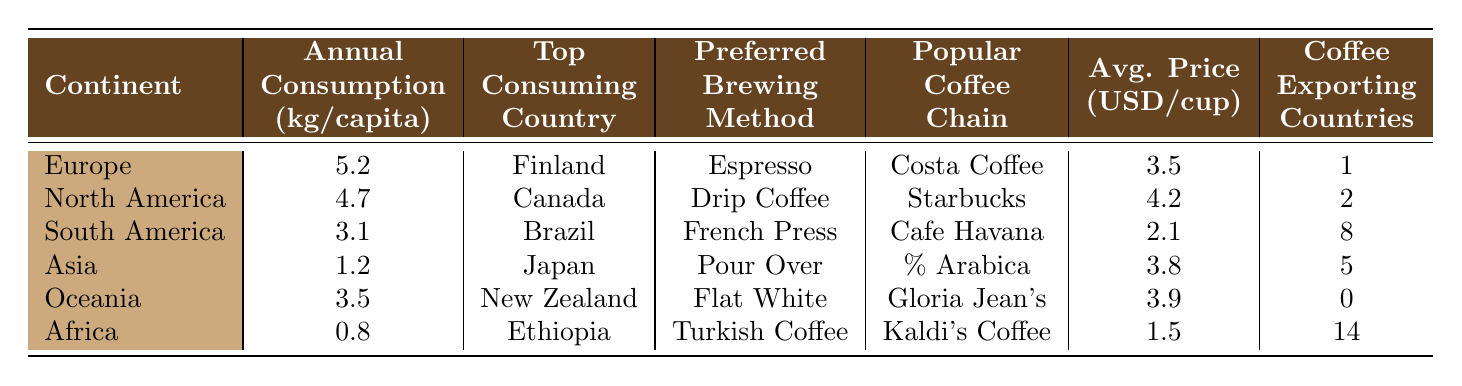What continent has the highest annual coffee consumption per capita? By examining the "Annual Consumption Kg Per Capita" column, Europe has the highest value at 5.2 kg per capita.
Answer: Europe Which continent has the lowest coffee consumption per capita? Referring to the same column, Africa has the lowest consumption at 0.8 kg per capita.
Answer: Africa What is the preferred brewing method in South America? Looking at the "Preferred Brewing Method" column for South America, the method is French Press.
Answer: French Press How much does a cup of coffee cost on average in North America? From the "Avg. Price (USD/cup)" column, the average price per cup in North America is 4.2 USD.
Answer: 4.2 USD Which two continents have the same preferred brewing method? By comparing the "Preferred Brewing Method" column, there are no two continents that share the same preferred brewing method, which indicates all are unique.
Answer: No continents share preferred brewing methods What is the total number of coffee exporting countries across all continents? Summing the values in the "Coffee Exporting Countries" column gives 1 + 2 + 8 + 5 + 0 + 14 = 30, indicating a total of 30 coffee exporting countries.
Answer: 30 Which country has the highest estimated annual coffee consumption per capita? Finland, as indicated under "Top Consuming Country" for Europe, has the highest consumption value of 5.2 kg per capita.
Answer: Finland Is the average price of coffee higher in Oceania than in Africa? By comparing values, Oceania has an average price of 3.9 USD, while Africa has 1.5 USD, confirming Oceania's higher price.
Answer: Yes What is the average annual coffee consumption per capita for the continents which prefer "Flat White" and "Turkish Coffee"? Average = (3.5 + 0.8) / 2 = 2.15 kg, combining Oceania’s 3.5 kg and Africa’s 0.8 kg to find the mean.
Answer: 2.15 kg Which popular coffee chain is listed for Asia? The "Popular Coffee Chain" for Asia is % Arabica, as specified in the corresponding row.
Answer: % Arabica 